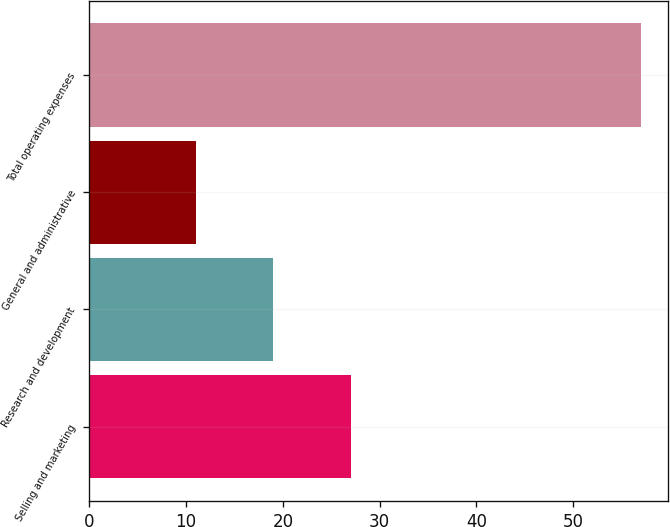Convert chart to OTSL. <chart><loc_0><loc_0><loc_500><loc_500><bar_chart><fcel>Selling and marketing<fcel>Research and development<fcel>General and administrative<fcel>Total operating expenses<nl><fcel>27<fcel>19<fcel>11<fcel>57<nl></chart> 